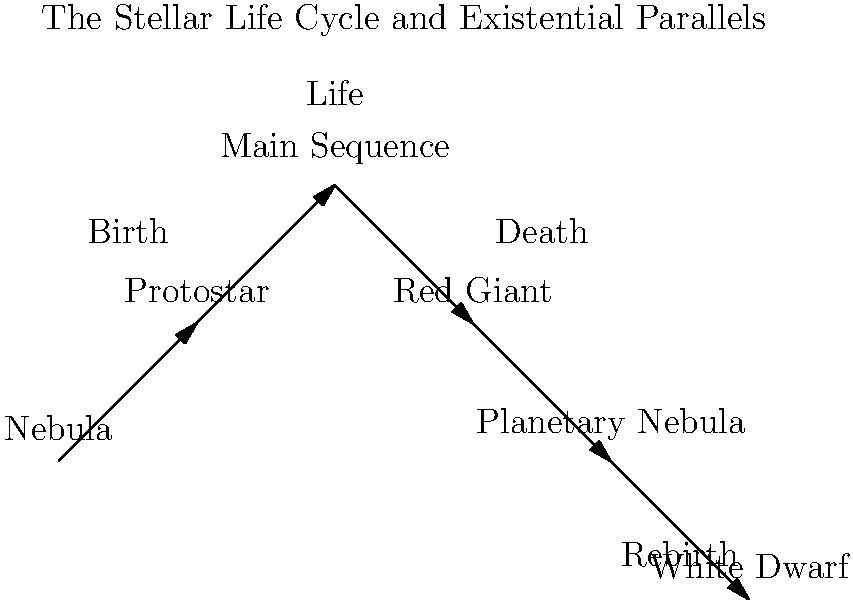In the context of the stellar life cycle diagram, which stage most closely aligns with the existential concept of "being-towards-death" as described by Martin Heidegger, and why might this parallel be significant for our understanding of human existence? To answer this question, let's break down the concepts and analyze the diagram:

1. Understanding "being-towards-death":
   - Heidegger's concept emphasizes that awareness of our mortality shapes our existence.
   - It suggests that recognizing our finite nature gives meaning to our choices and actions.

2. Analyzing the stellar life cycle:
   - Nebula: Birth of potential
   - Protostar: Early formation
   - Main Sequence: Stable existence
   - Red Giant: Expansion and transformation
   - Planetary Nebula: Shedding of outer layers
   - White Dwarf: Final, stable state

3. Identifying the parallel:
   - The Red Giant stage most closely aligns with "being-towards-death"
   - It represents a phase of expansion and transformation before the star's end

4. Significance of the parallel:
   - Just as a star's Red Giant phase is a period of significant change and energy release, human awareness of mortality can lead to profound personal growth and meaningful action.
   - The Red Giant stage, like "being-towards-death," is not the end itself but a transformative period leading to it.
   - This parallel suggests that confronting our mortality can lead to a more authentic and purposeful existence.

5. Philosophical implications:
   - The stellar life cycle illustrates the cyclical nature of existence, from birth to death and potential rebirth (in the form of new stars from remnant material).
   - This cycle reflects existential themes of creation, purpose, transformation, and legacy.

6. Introspective consideration:
   - As an author of existential works, this parallel invites reflection on how awareness of our finite nature can inspire us to create lasting impacts through our actions and creations.
Answer: Red Giant stage, representing transformative awareness of finitude leading to authentic existence. 